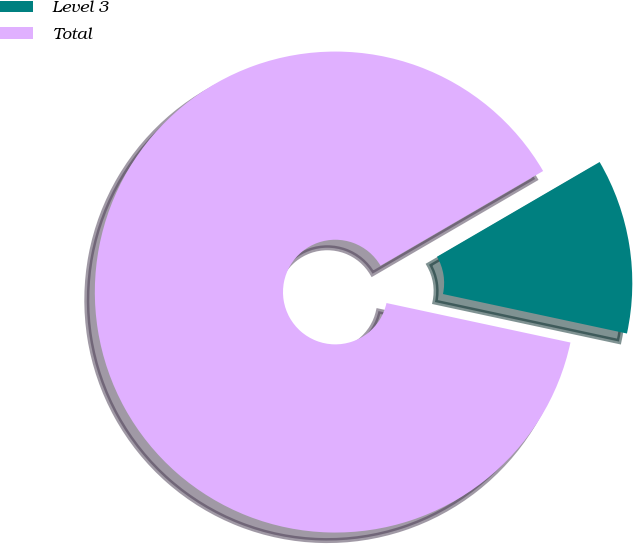Convert chart to OTSL. <chart><loc_0><loc_0><loc_500><loc_500><pie_chart><fcel>Level 3<fcel>Total<nl><fcel>11.76%<fcel>88.24%<nl></chart> 